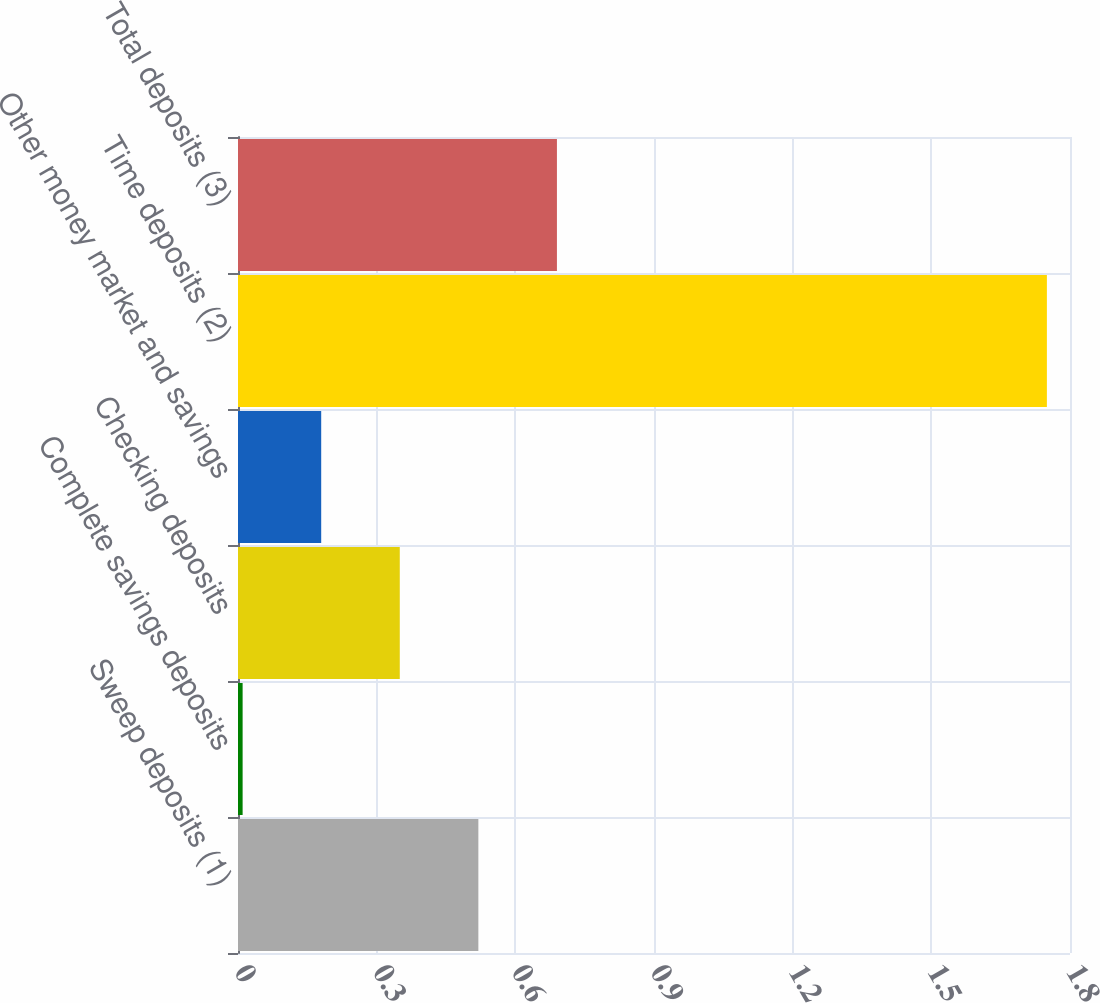Convert chart. <chart><loc_0><loc_0><loc_500><loc_500><bar_chart><fcel>Sweep deposits (1)<fcel>Complete savings deposits<fcel>Checking deposits<fcel>Other money market and savings<fcel>Time deposits (2)<fcel>Total deposits (3)<nl><fcel>0.52<fcel>0.01<fcel>0.35<fcel>0.18<fcel>1.75<fcel>0.69<nl></chart> 